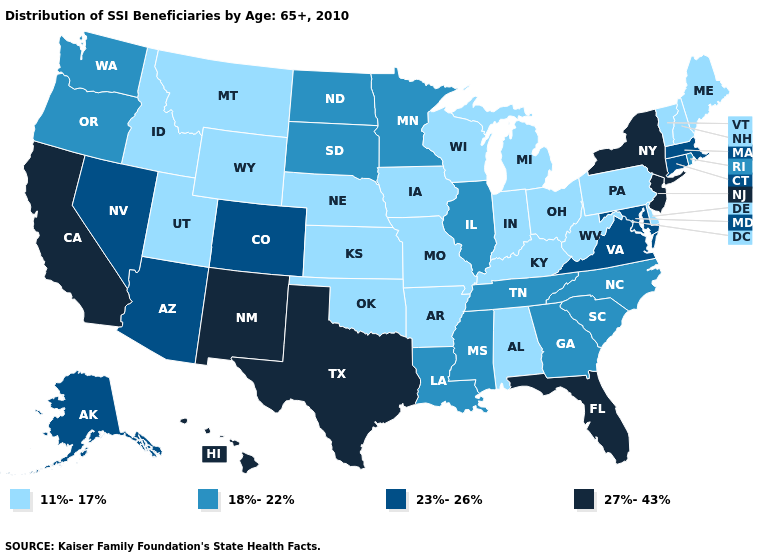Name the states that have a value in the range 23%-26%?
Write a very short answer. Alaska, Arizona, Colorado, Connecticut, Maryland, Massachusetts, Nevada, Virginia. Does Ohio have the same value as Mississippi?
Give a very brief answer. No. Name the states that have a value in the range 11%-17%?
Be succinct. Alabama, Arkansas, Delaware, Idaho, Indiana, Iowa, Kansas, Kentucky, Maine, Michigan, Missouri, Montana, Nebraska, New Hampshire, Ohio, Oklahoma, Pennsylvania, Utah, Vermont, West Virginia, Wisconsin, Wyoming. What is the lowest value in the MidWest?
Give a very brief answer. 11%-17%. Which states have the highest value in the USA?
Write a very short answer. California, Florida, Hawaii, New Jersey, New Mexico, New York, Texas. Name the states that have a value in the range 11%-17%?
Answer briefly. Alabama, Arkansas, Delaware, Idaho, Indiana, Iowa, Kansas, Kentucky, Maine, Michigan, Missouri, Montana, Nebraska, New Hampshire, Ohio, Oklahoma, Pennsylvania, Utah, Vermont, West Virginia, Wisconsin, Wyoming. Does the map have missing data?
Quick response, please. No. Does New Hampshire have the lowest value in the Northeast?
Be succinct. Yes. Is the legend a continuous bar?
Write a very short answer. No. Does Florida have the highest value in the USA?
Short answer required. Yes. Name the states that have a value in the range 23%-26%?
Keep it brief. Alaska, Arizona, Colorado, Connecticut, Maryland, Massachusetts, Nevada, Virginia. Does the map have missing data?
Write a very short answer. No. Name the states that have a value in the range 18%-22%?
Concise answer only. Georgia, Illinois, Louisiana, Minnesota, Mississippi, North Carolina, North Dakota, Oregon, Rhode Island, South Carolina, South Dakota, Tennessee, Washington. What is the value of Alaska?
Keep it brief. 23%-26%. What is the value of Idaho?
Quick response, please. 11%-17%. 